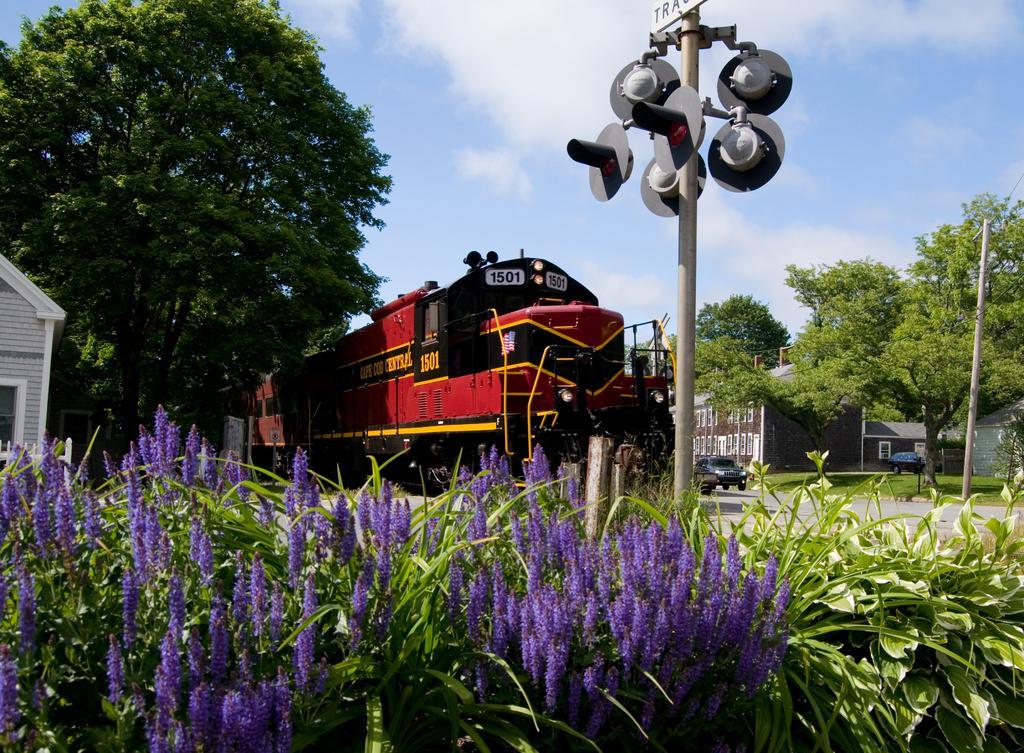Could you give a brief overview of what you see in this image? In the center of the image there is a train. At the bottom of the image we can see plants. On the right side there are trees, houses, vehicles and traffic signals. On the left side we can see house and trees. In the background there is a sky and clouds. 